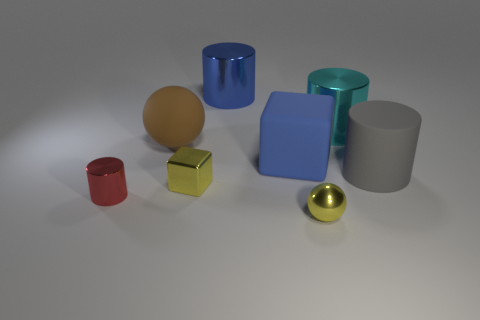Subtract all big cylinders. How many cylinders are left? 1 Subtract 1 cylinders. How many cylinders are left? 3 Subtract all blue cylinders. How many cylinders are left? 3 Subtract all cyan cylinders. Subtract all purple cubes. How many cylinders are left? 3 Subtract all balls. How many objects are left? 6 Add 1 tiny red cylinders. How many objects exist? 9 Subtract 0 brown blocks. How many objects are left? 8 Subtract all big brown rubber balls. Subtract all small yellow balls. How many objects are left? 6 Add 4 small metal blocks. How many small metal blocks are left? 5 Add 5 tiny red cubes. How many tiny red cubes exist? 5 